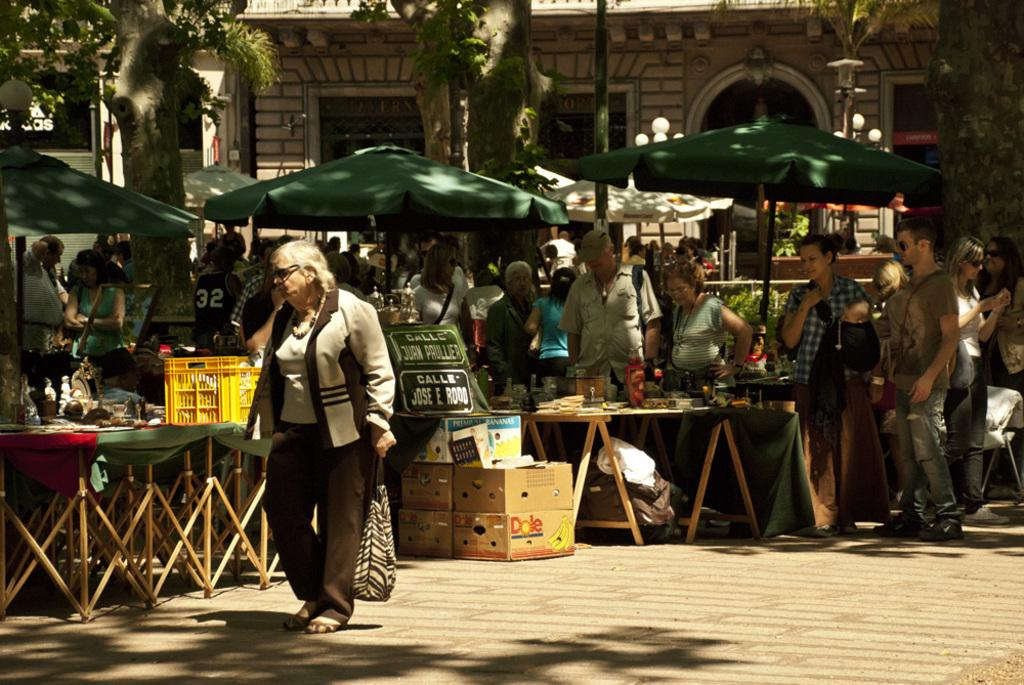<image>
Render a clear and concise summary of the photo. A woman walking past a sign that says CalleJose E. Rodo. 